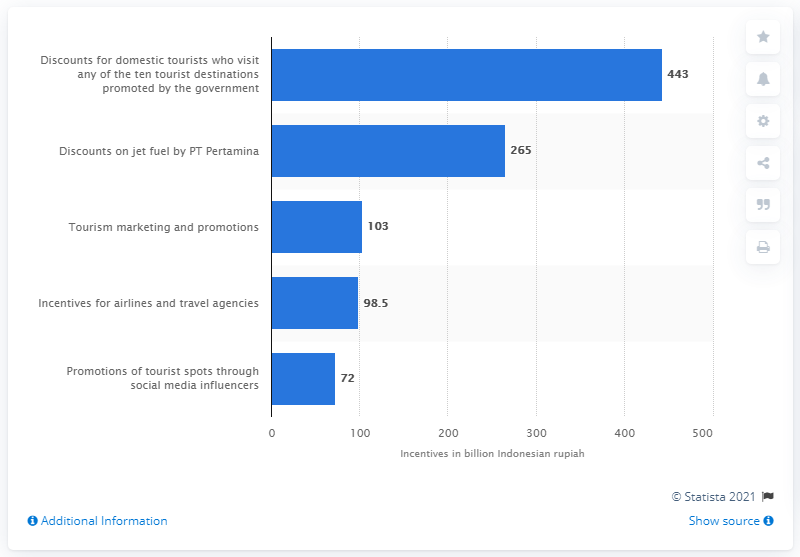Draw attention to some important aspects in this diagram. As of February 2020, the Indonesian government had set aside 443,000 Indonesian rupiah for a specific purpose. 